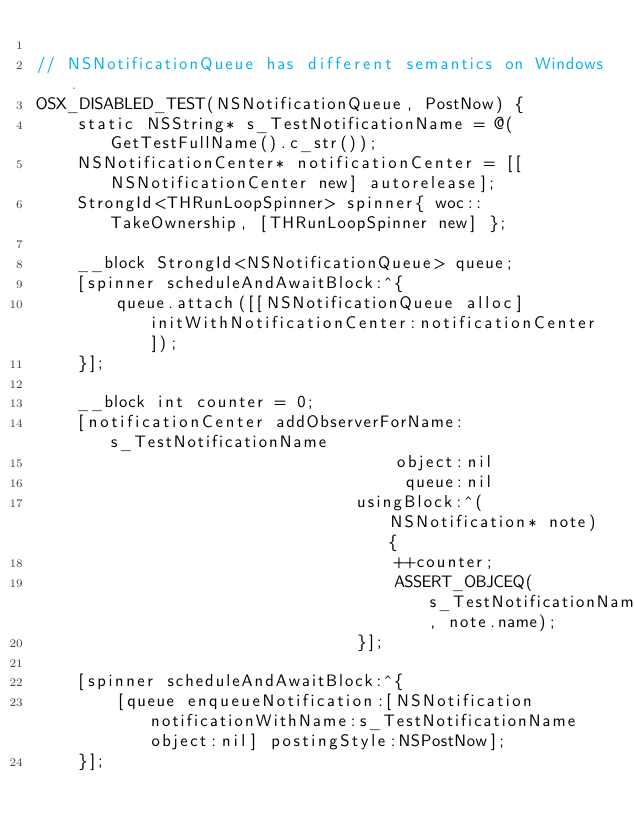Convert code to text. <code><loc_0><loc_0><loc_500><loc_500><_ObjectiveC_>
// NSNotificationQueue has different semantics on Windows.
OSX_DISABLED_TEST(NSNotificationQueue, PostNow) {
    static NSString* s_TestNotificationName = @(GetTestFullName().c_str());
    NSNotificationCenter* notificationCenter = [[NSNotificationCenter new] autorelease];
    StrongId<THRunLoopSpinner> spinner{ woc::TakeOwnership, [THRunLoopSpinner new] };

    __block StrongId<NSNotificationQueue> queue;
    [spinner scheduleAndAwaitBlock:^{
        queue.attach([[NSNotificationQueue alloc] initWithNotificationCenter:notificationCenter]);
    }];

    __block int counter = 0;
    [notificationCenter addObserverForName:s_TestNotificationName
                                    object:nil
                                     queue:nil
                                usingBlock:^(NSNotification* note) {
                                    ++counter;
                                    ASSERT_OBJCEQ(s_TestNotificationName, note.name);
                                }];

    [spinner scheduleAndAwaitBlock:^{
        [queue enqueueNotification:[NSNotification notificationWithName:s_TestNotificationName object:nil] postingStyle:NSPostNow];
    }];
</code> 